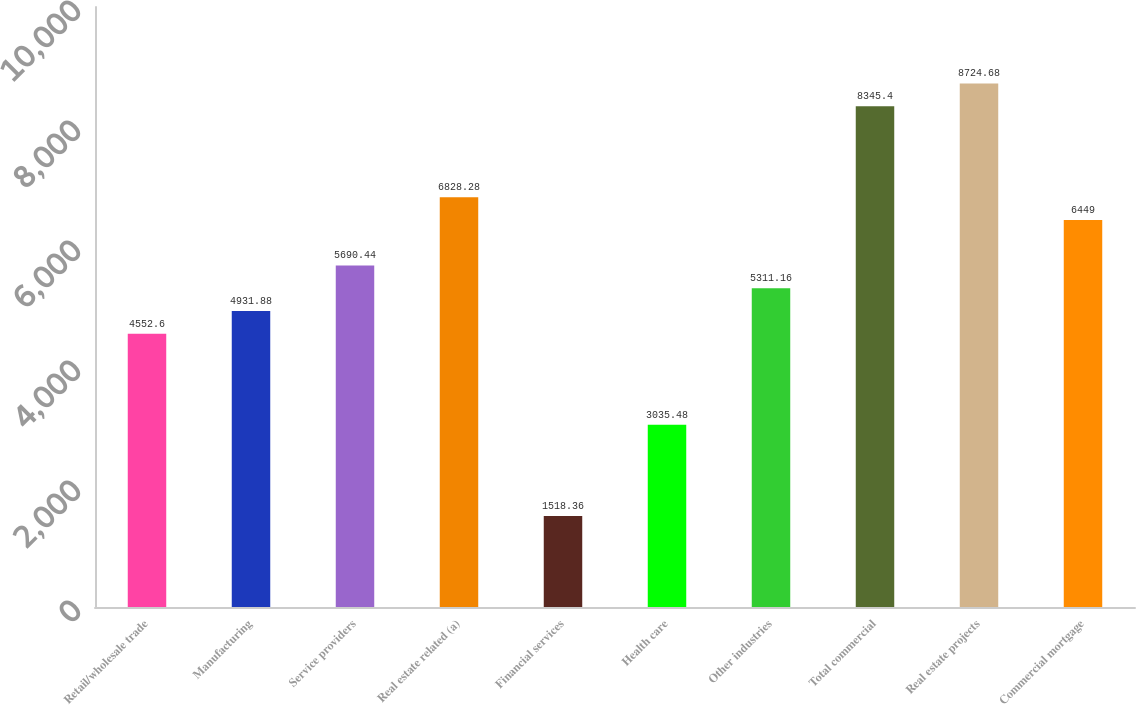Convert chart. <chart><loc_0><loc_0><loc_500><loc_500><bar_chart><fcel>Retail/wholesale trade<fcel>Manufacturing<fcel>Service providers<fcel>Real estate related (a)<fcel>Financial services<fcel>Health care<fcel>Other industries<fcel>Total commercial<fcel>Real estate projects<fcel>Commercial mortgage<nl><fcel>4552.6<fcel>4931.88<fcel>5690.44<fcel>6828.28<fcel>1518.36<fcel>3035.48<fcel>5311.16<fcel>8345.4<fcel>8724.68<fcel>6449<nl></chart> 